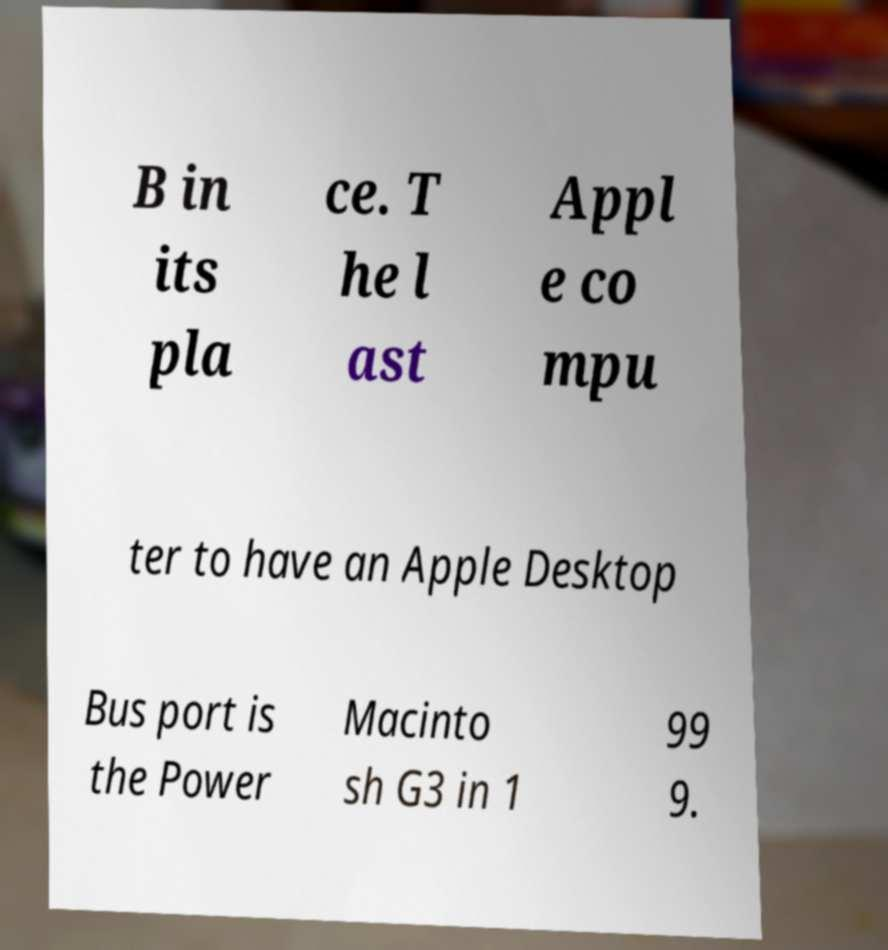Could you extract and type out the text from this image? B in its pla ce. T he l ast Appl e co mpu ter to have an Apple Desktop Bus port is the Power Macinto sh G3 in 1 99 9. 